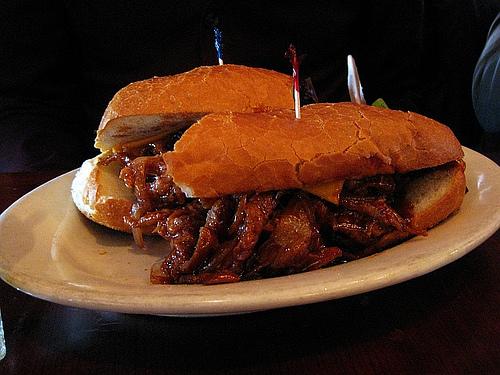What vegetable is sticking out of the burger?
Keep it brief. Onions. Does this look like a messy meal?
Quick response, please. Yes. What kind of meat is this?
Give a very brief answer. Pork. How many calories are in this sandwich?
Short answer required. 900. What color are the toothpicks?
Short answer required. Red and blue. 